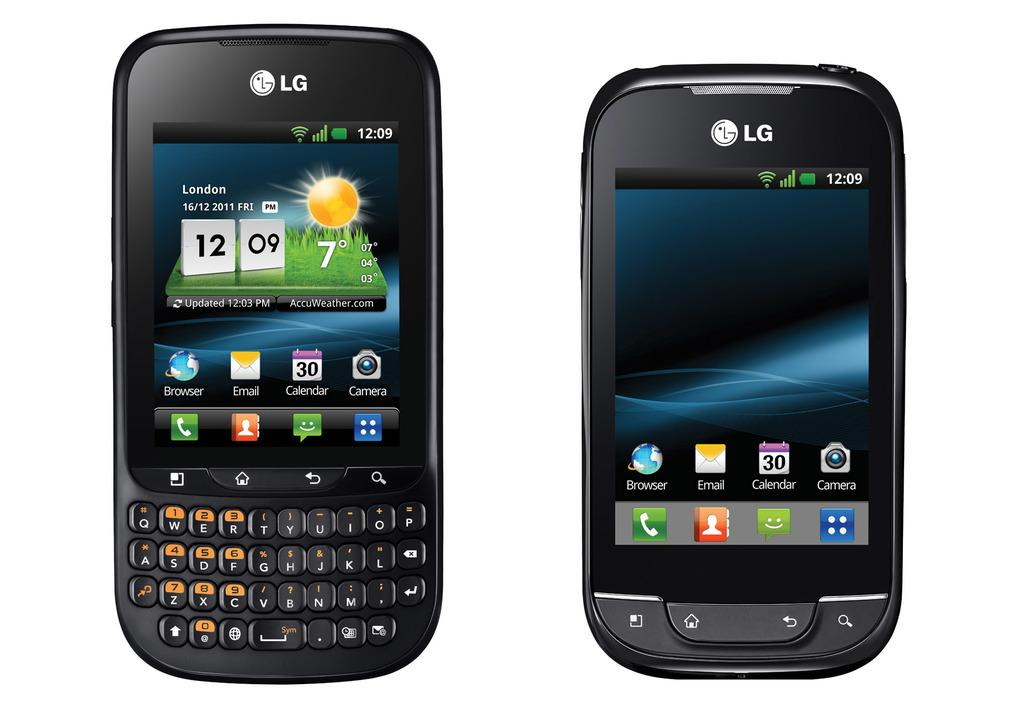<image>
Summarize the visual content of the image. 16/12/2011 London is displayed on this LG smart phone. 